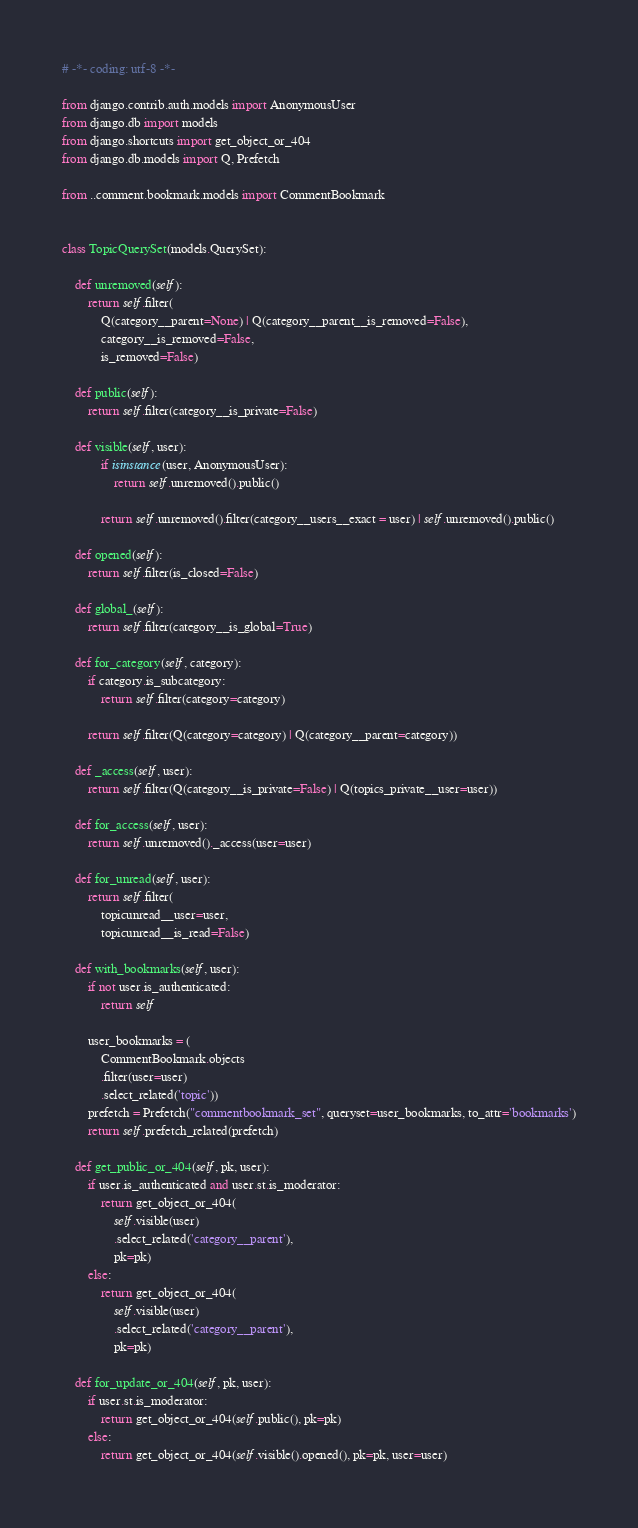<code> <loc_0><loc_0><loc_500><loc_500><_Python_># -*- coding: utf-8 -*-

from django.contrib.auth.models import AnonymousUser
from django.db import models
from django.shortcuts import get_object_or_404
from django.db.models import Q, Prefetch

from ..comment.bookmark.models import CommentBookmark


class TopicQuerySet(models.QuerySet):

    def unremoved(self):
        return self.filter(
            Q(category__parent=None) | Q(category__parent__is_removed=False),
            category__is_removed=False,
            is_removed=False)

    def public(self):
        return self.filter(category__is_private=False)

    def visible(self, user):
            if isinstance(user, AnonymousUser):
                return self.unremoved().public()

            return self.unremoved().filter(category__users__exact = user) | self.unremoved().public()

    def opened(self):
        return self.filter(is_closed=False)

    def global_(self):
        return self.filter(category__is_global=True)

    def for_category(self, category):
        if category.is_subcategory:
            return self.filter(category=category)

        return self.filter(Q(category=category) | Q(category__parent=category))

    def _access(self, user):
        return self.filter(Q(category__is_private=False) | Q(topics_private__user=user))

    def for_access(self, user):
        return self.unremoved()._access(user=user)

    def for_unread(self, user):
        return self.filter(
            topicunread__user=user,
            topicunread__is_read=False)

    def with_bookmarks(self, user):
        if not user.is_authenticated:
            return self

        user_bookmarks = (
            CommentBookmark.objects
            .filter(user=user)
            .select_related('topic'))
        prefetch = Prefetch("commentbookmark_set", queryset=user_bookmarks, to_attr='bookmarks')
        return self.prefetch_related(prefetch)

    def get_public_or_404(self, pk, user):
        if user.is_authenticated and user.st.is_moderator:
            return get_object_or_404(
                self.visible(user)
                .select_related('category__parent'),
                pk=pk)
        else:
            return get_object_or_404(
                self.visible(user)
                .select_related('category__parent'),
                pk=pk)

    def for_update_or_404(self, pk, user):
        if user.st.is_moderator:
            return get_object_or_404(self.public(), pk=pk)
        else:
            return get_object_or_404(self.visible().opened(), pk=pk, user=user)
</code> 